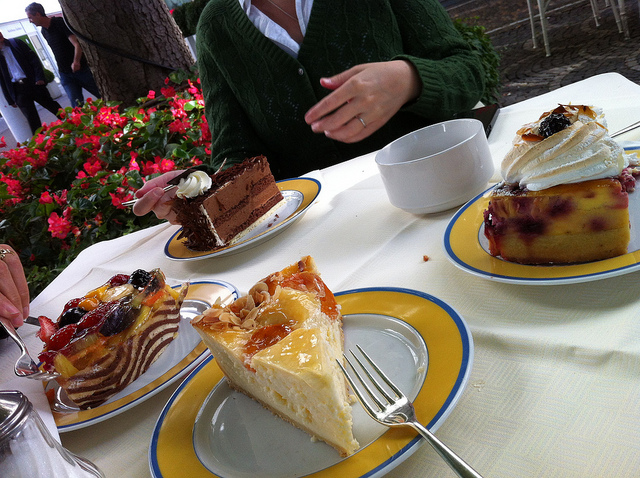Can you describe the setting where these cakes are being enjoyed? Certainly! The cakes are presented on a table at what appears to be an outdoor cafe or garden setting. The plates are set on top of a table covered with a white cloth, suggesting a leisurely dining scenario. There's lush greenery in the background hinting at a peaceful and relaxing environment, perfect for enjoying a sweet treat. 